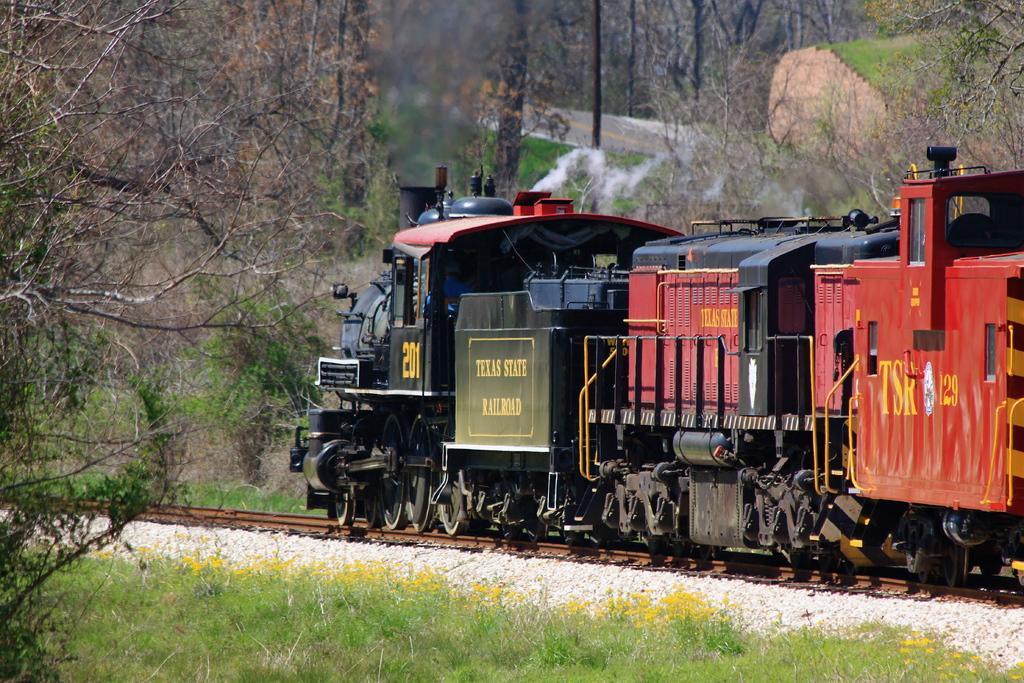Describe this image in one or two sentences. In this image there is a train on a track, on either side of the train there are trees. 